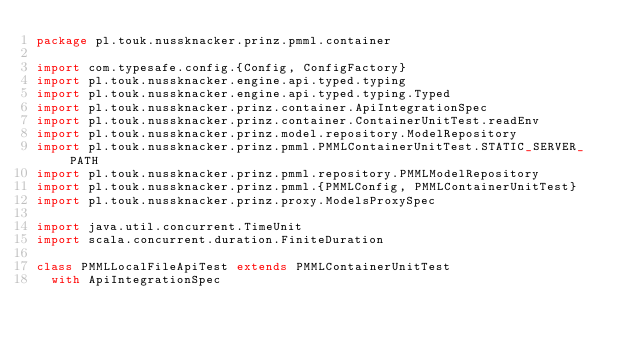Convert code to text. <code><loc_0><loc_0><loc_500><loc_500><_Scala_>package pl.touk.nussknacker.prinz.pmml.container

import com.typesafe.config.{Config, ConfigFactory}
import pl.touk.nussknacker.engine.api.typed.typing
import pl.touk.nussknacker.engine.api.typed.typing.Typed
import pl.touk.nussknacker.prinz.container.ApiIntegrationSpec
import pl.touk.nussknacker.prinz.container.ContainerUnitTest.readEnv
import pl.touk.nussknacker.prinz.model.repository.ModelRepository
import pl.touk.nussknacker.prinz.pmml.PMMLContainerUnitTest.STATIC_SERVER_PATH
import pl.touk.nussknacker.prinz.pmml.repository.PMMLModelRepository
import pl.touk.nussknacker.prinz.pmml.{PMMLConfig, PMMLContainerUnitTest}
import pl.touk.nussknacker.prinz.proxy.ModelsProxySpec

import java.util.concurrent.TimeUnit
import scala.concurrent.duration.FiniteDuration

class PMMLLocalFileApiTest extends PMMLContainerUnitTest
  with ApiIntegrationSpec</code> 